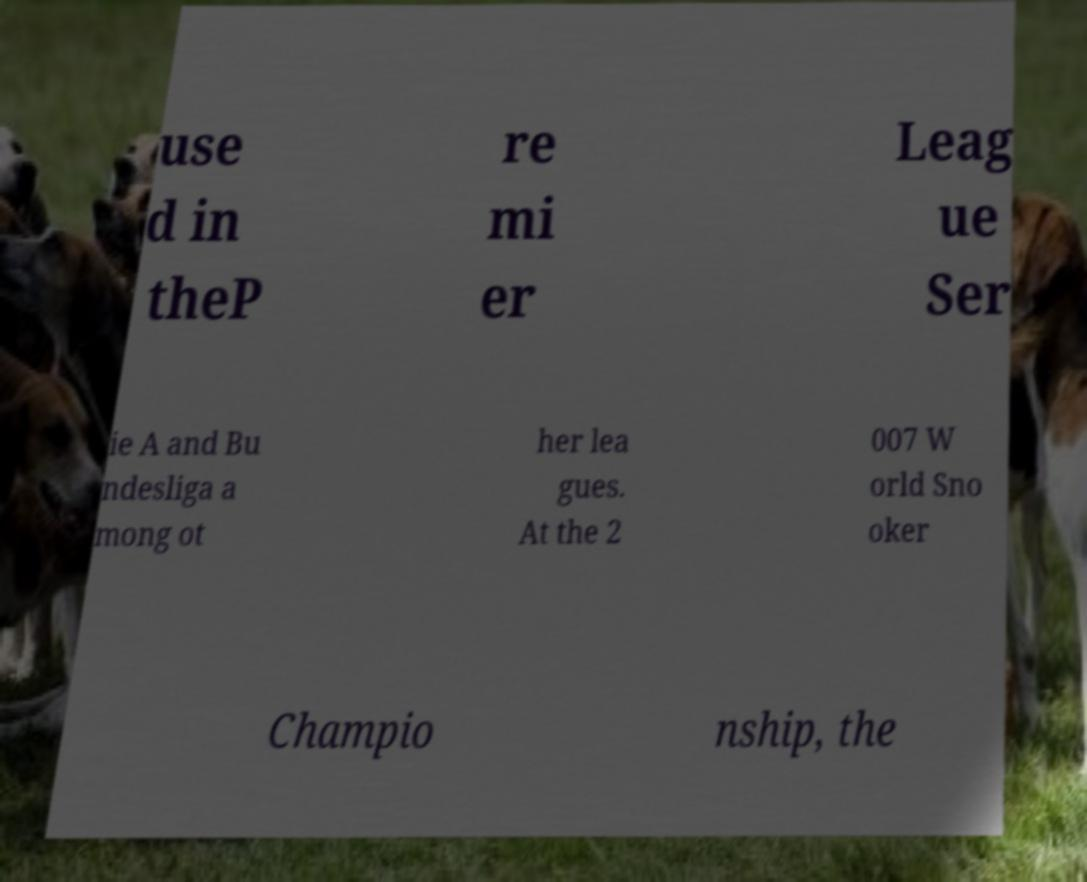Please read and relay the text visible in this image. What does it say? use d in theP re mi er Leag ue Ser ie A and Bu ndesliga a mong ot her lea gues. At the 2 007 W orld Sno oker Champio nship, the 